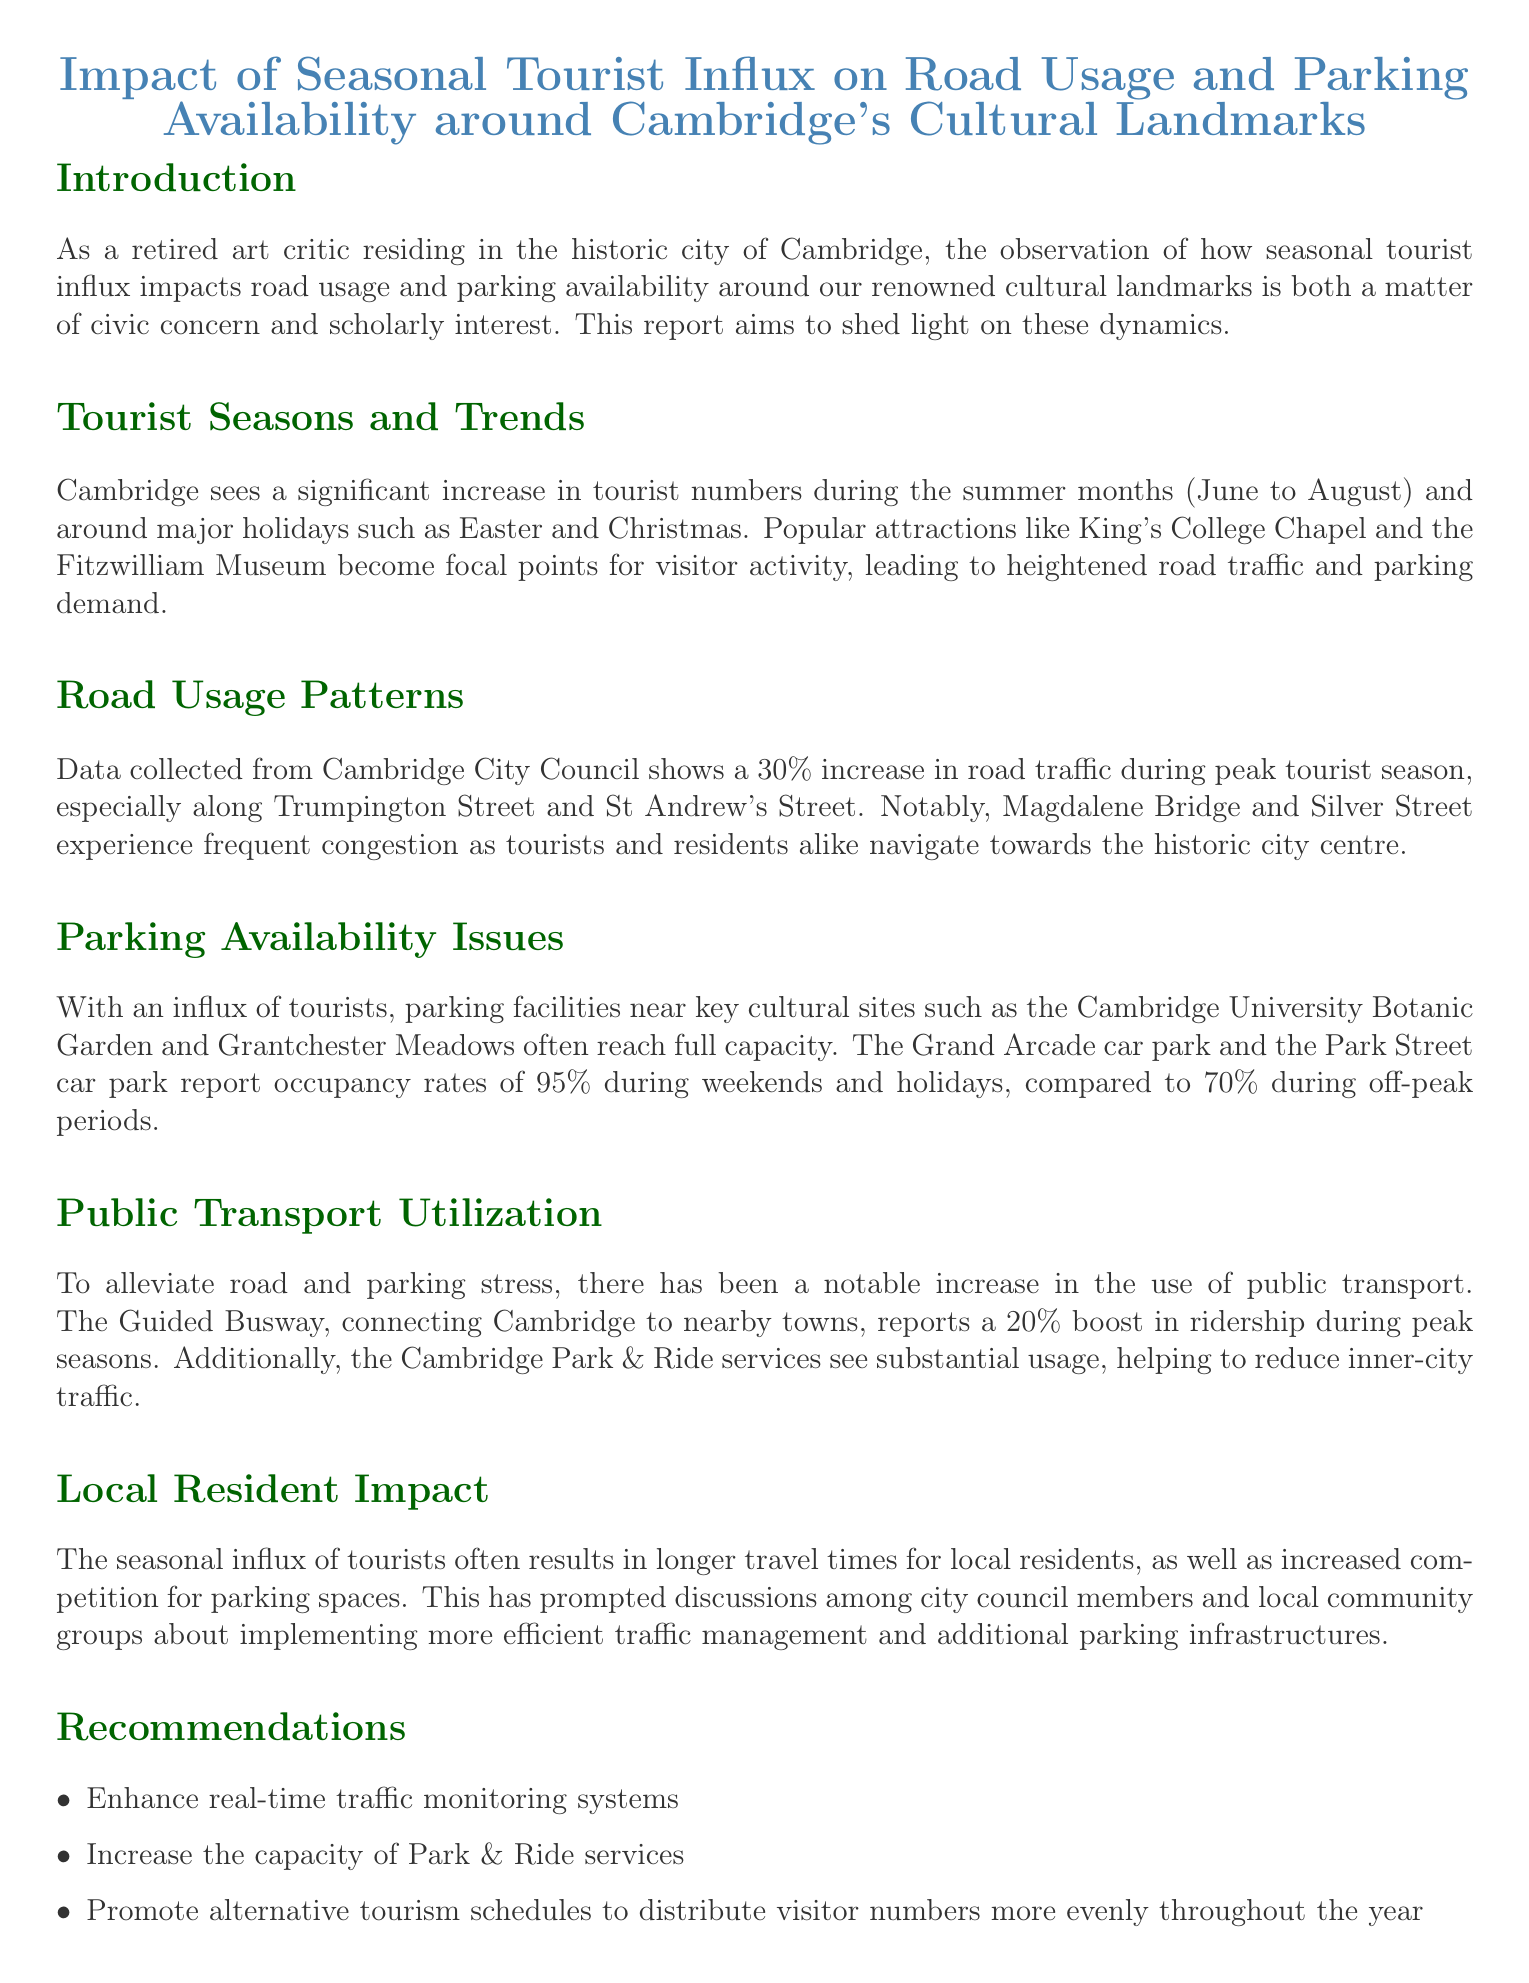what is the increase in road traffic during peak tourist season? The report states that there is a 30% increase in road traffic during the peak tourist season.
Answer: 30% which streets experience frequent congestion? The streets mentioned in the report that experience frequent congestion are Trumpington Street and St Andrew's Street.
Answer: Trumpington Street and St Andrew's Street what is the occupancy rate of the Grand Arcade car park during weekends? According to the document, the Grand Arcade car park reports occupancy rates of 95% during weekends.
Answer: 95% how much has public transport ridership increased during peak seasons? The report indicates a 20% boost in ridership for public transport during peak seasons.
Answer: 20% which cultural site experiences parking capacity issues? The Cambridge University Botanic Garden is highlighted as a site that experiences parking capacity issues.
Answer: Cambridge University Botanic Garden what is a recommendation for traffic management mentioned in the report? One recommendation provided in the report is to enhance real-time traffic monitoring systems.
Answer: Enhance real-time traffic monitoring systems how does the seasonal tourist influx affect local residents? The seasonal influx leads to longer travel times for local residents and increased competition for parking spaces.
Answer: Longer travel times and increased competition for parking what type of report is this document? This document is a Traffic report focusing on the impact of seasonal tourist influx on road usage and parking availability.
Answer: Traffic report 